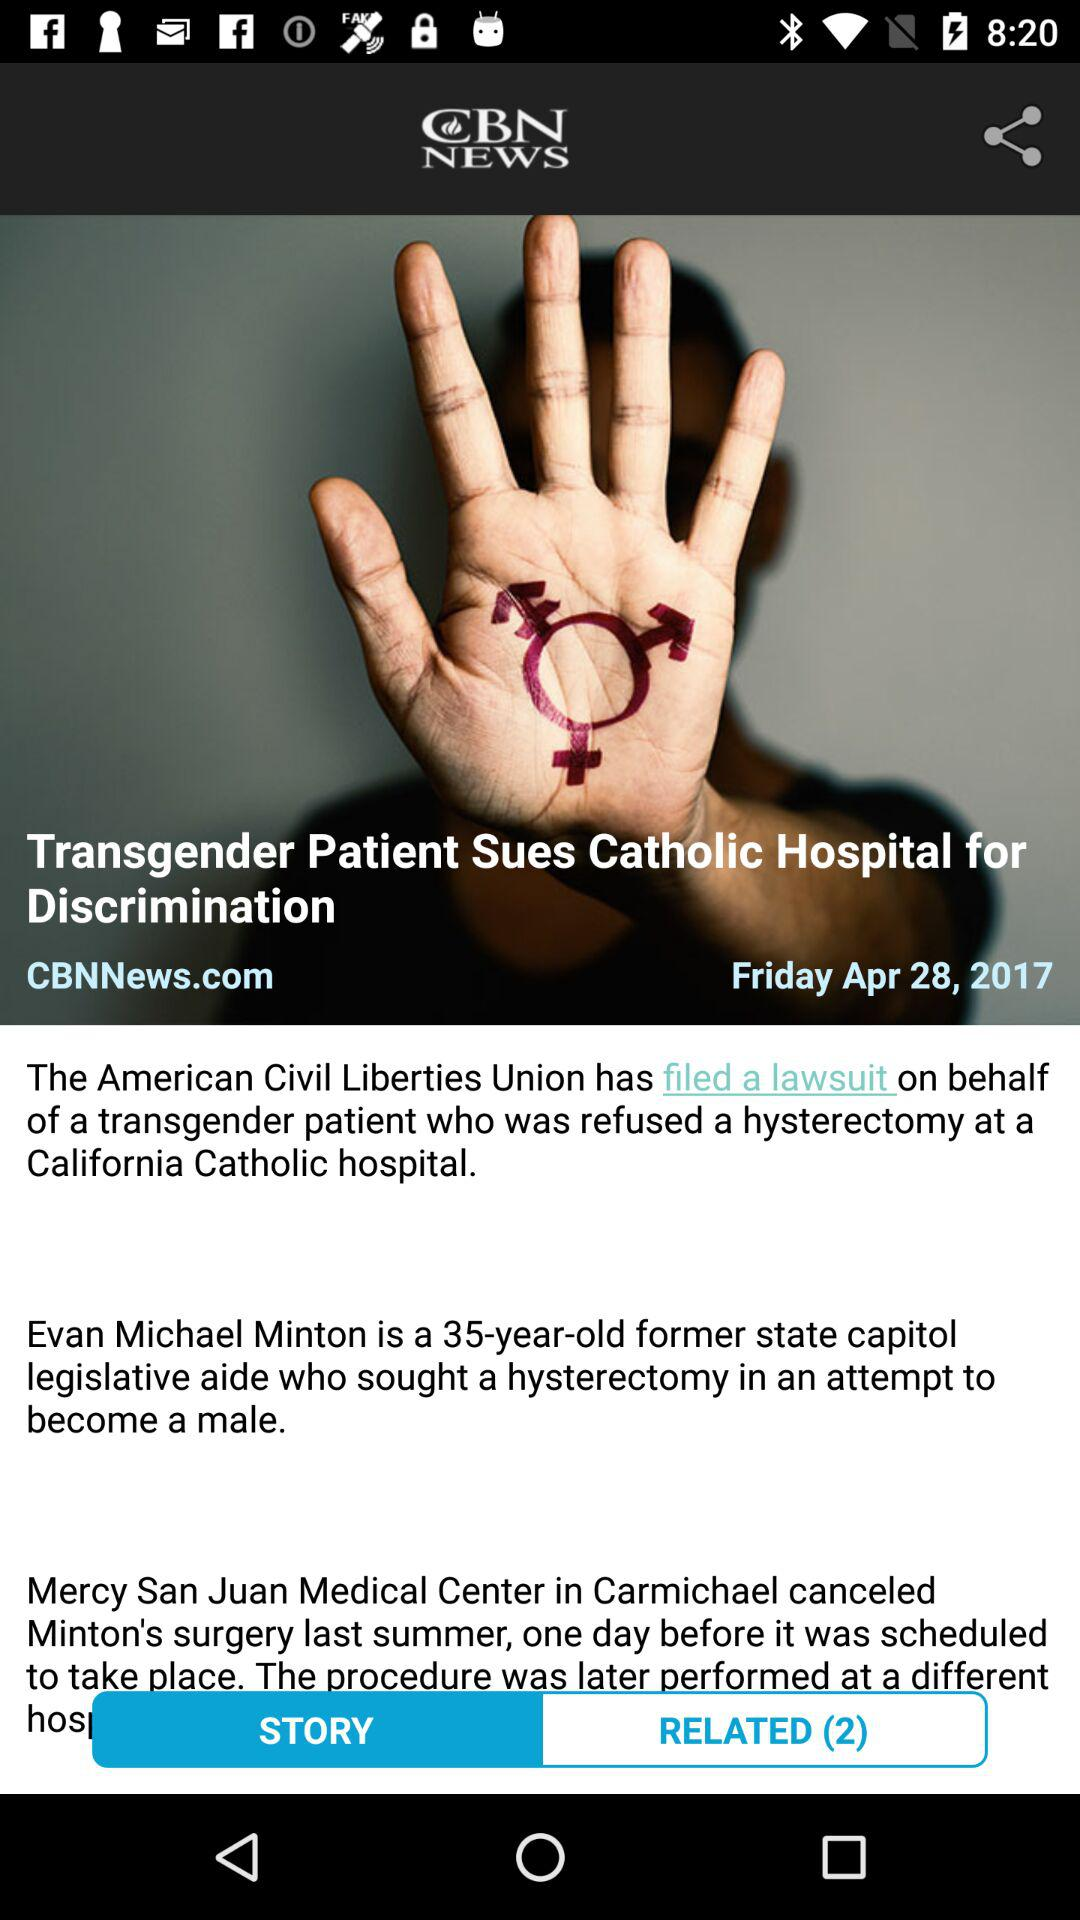How many days before the scheduled surgery did Mercy San Juan Medical Center cancel Minton's surgery?
Answer the question using a single word or phrase. 1 